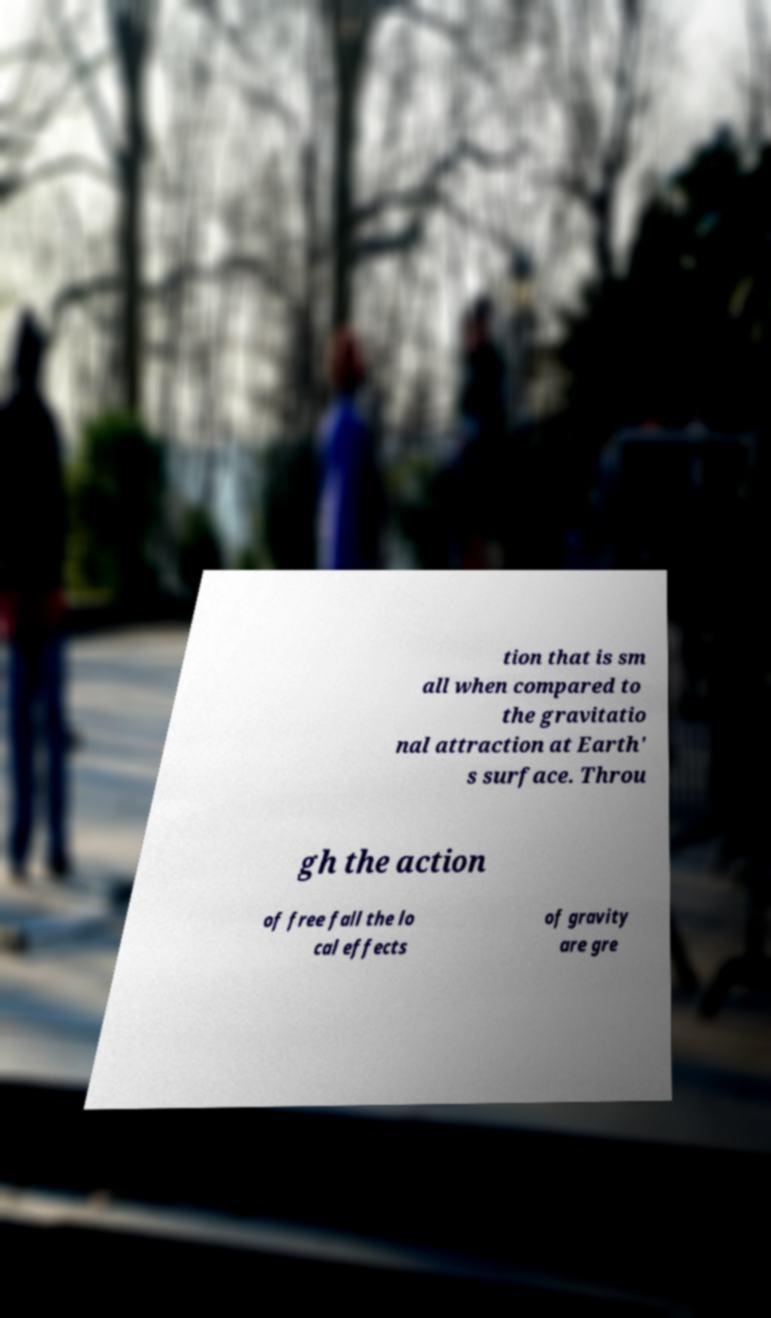For documentation purposes, I need the text within this image transcribed. Could you provide that? tion that is sm all when compared to the gravitatio nal attraction at Earth' s surface. Throu gh the action of free fall the lo cal effects of gravity are gre 